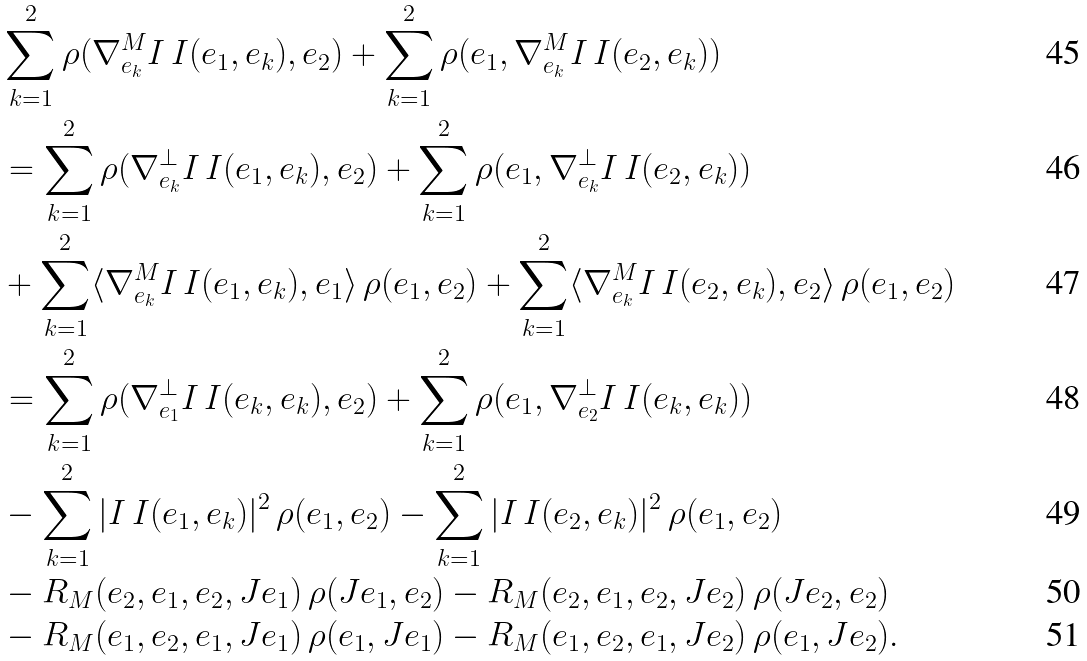<formula> <loc_0><loc_0><loc_500><loc_500>& \sum _ { k = 1 } ^ { 2 } \rho ( \nabla _ { e _ { k } } ^ { M } I \, I ( e _ { 1 } , e _ { k } ) , e _ { 2 } ) + \sum _ { k = 1 } ^ { 2 } \rho ( e _ { 1 } , \nabla _ { e _ { k } } ^ { M } I \, I ( e _ { 2 } , e _ { k } ) ) \\ & = \sum _ { k = 1 } ^ { 2 } \rho ( \nabla _ { e _ { k } } ^ { \perp } I \, I ( e _ { 1 } , e _ { k } ) , e _ { 2 } ) + \sum _ { k = 1 } ^ { 2 } \rho ( e _ { 1 } , \nabla _ { e _ { k } } ^ { \perp } I \, I ( e _ { 2 } , e _ { k } ) ) \\ & + \sum _ { k = 1 } ^ { 2 } \langle \nabla _ { e _ { k } } ^ { M } I \, I ( e _ { 1 } , e _ { k } ) , e _ { 1 } \rangle \, \rho ( e _ { 1 } , e _ { 2 } ) + \sum _ { k = 1 } ^ { 2 } \langle \nabla _ { e _ { k } } ^ { M } I \, I ( e _ { 2 } , e _ { k } ) , e _ { 2 } \rangle \, \rho ( e _ { 1 } , e _ { 2 } ) \\ & = \sum _ { k = 1 } ^ { 2 } \rho ( \nabla _ { e _ { 1 } } ^ { \perp } I \, I ( e _ { k } , e _ { k } ) , e _ { 2 } ) + \sum _ { k = 1 } ^ { 2 } \rho ( e _ { 1 } , \nabla _ { e _ { 2 } } ^ { \perp } I \, I ( e _ { k } , e _ { k } ) ) \\ & - \sum _ { k = 1 } ^ { 2 } | I \, I ( e _ { 1 } , e _ { k } ) | ^ { 2 } \, \rho ( e _ { 1 } , e _ { 2 } ) - \sum _ { k = 1 } ^ { 2 } | I \, I ( e _ { 2 } , e _ { k } ) | ^ { 2 } \, \rho ( e _ { 1 } , e _ { 2 } ) \\ & - R _ { M } ( e _ { 2 } , e _ { 1 } , e _ { 2 } , J e _ { 1 } ) \, \rho ( J e _ { 1 } , e _ { 2 } ) - R _ { M } ( e _ { 2 } , e _ { 1 } , e _ { 2 } , J e _ { 2 } ) \, \rho ( J e _ { 2 } , e _ { 2 } ) \\ & - R _ { M } ( e _ { 1 } , e _ { 2 } , e _ { 1 } , J e _ { 1 } ) \, \rho ( e _ { 1 } , J e _ { 1 } ) - R _ { M } ( e _ { 1 } , e _ { 2 } , e _ { 1 } , J e _ { 2 } ) \, \rho ( e _ { 1 } , J e _ { 2 } ) .</formula> 